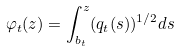Convert formula to latex. <formula><loc_0><loc_0><loc_500><loc_500>\varphi _ { t } ( z ) = \int _ { b _ { t } } ^ { z } ( q _ { t } ( s ) ) ^ { 1 / 2 } d s</formula> 